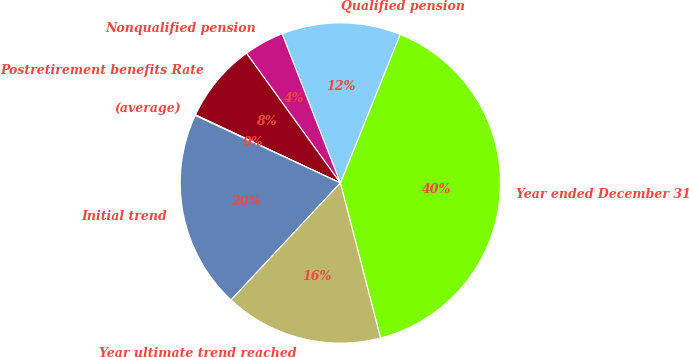Convert chart. <chart><loc_0><loc_0><loc_500><loc_500><pie_chart><fcel>Year ended December 31<fcel>Qualified pension<fcel>Nonqualified pension<fcel>Postretirement benefits Rate<fcel>(average)<fcel>Initial trend<fcel>Year ultimate trend reached<nl><fcel>39.88%<fcel>12.01%<fcel>4.05%<fcel>8.03%<fcel>0.07%<fcel>19.97%<fcel>15.99%<nl></chart> 